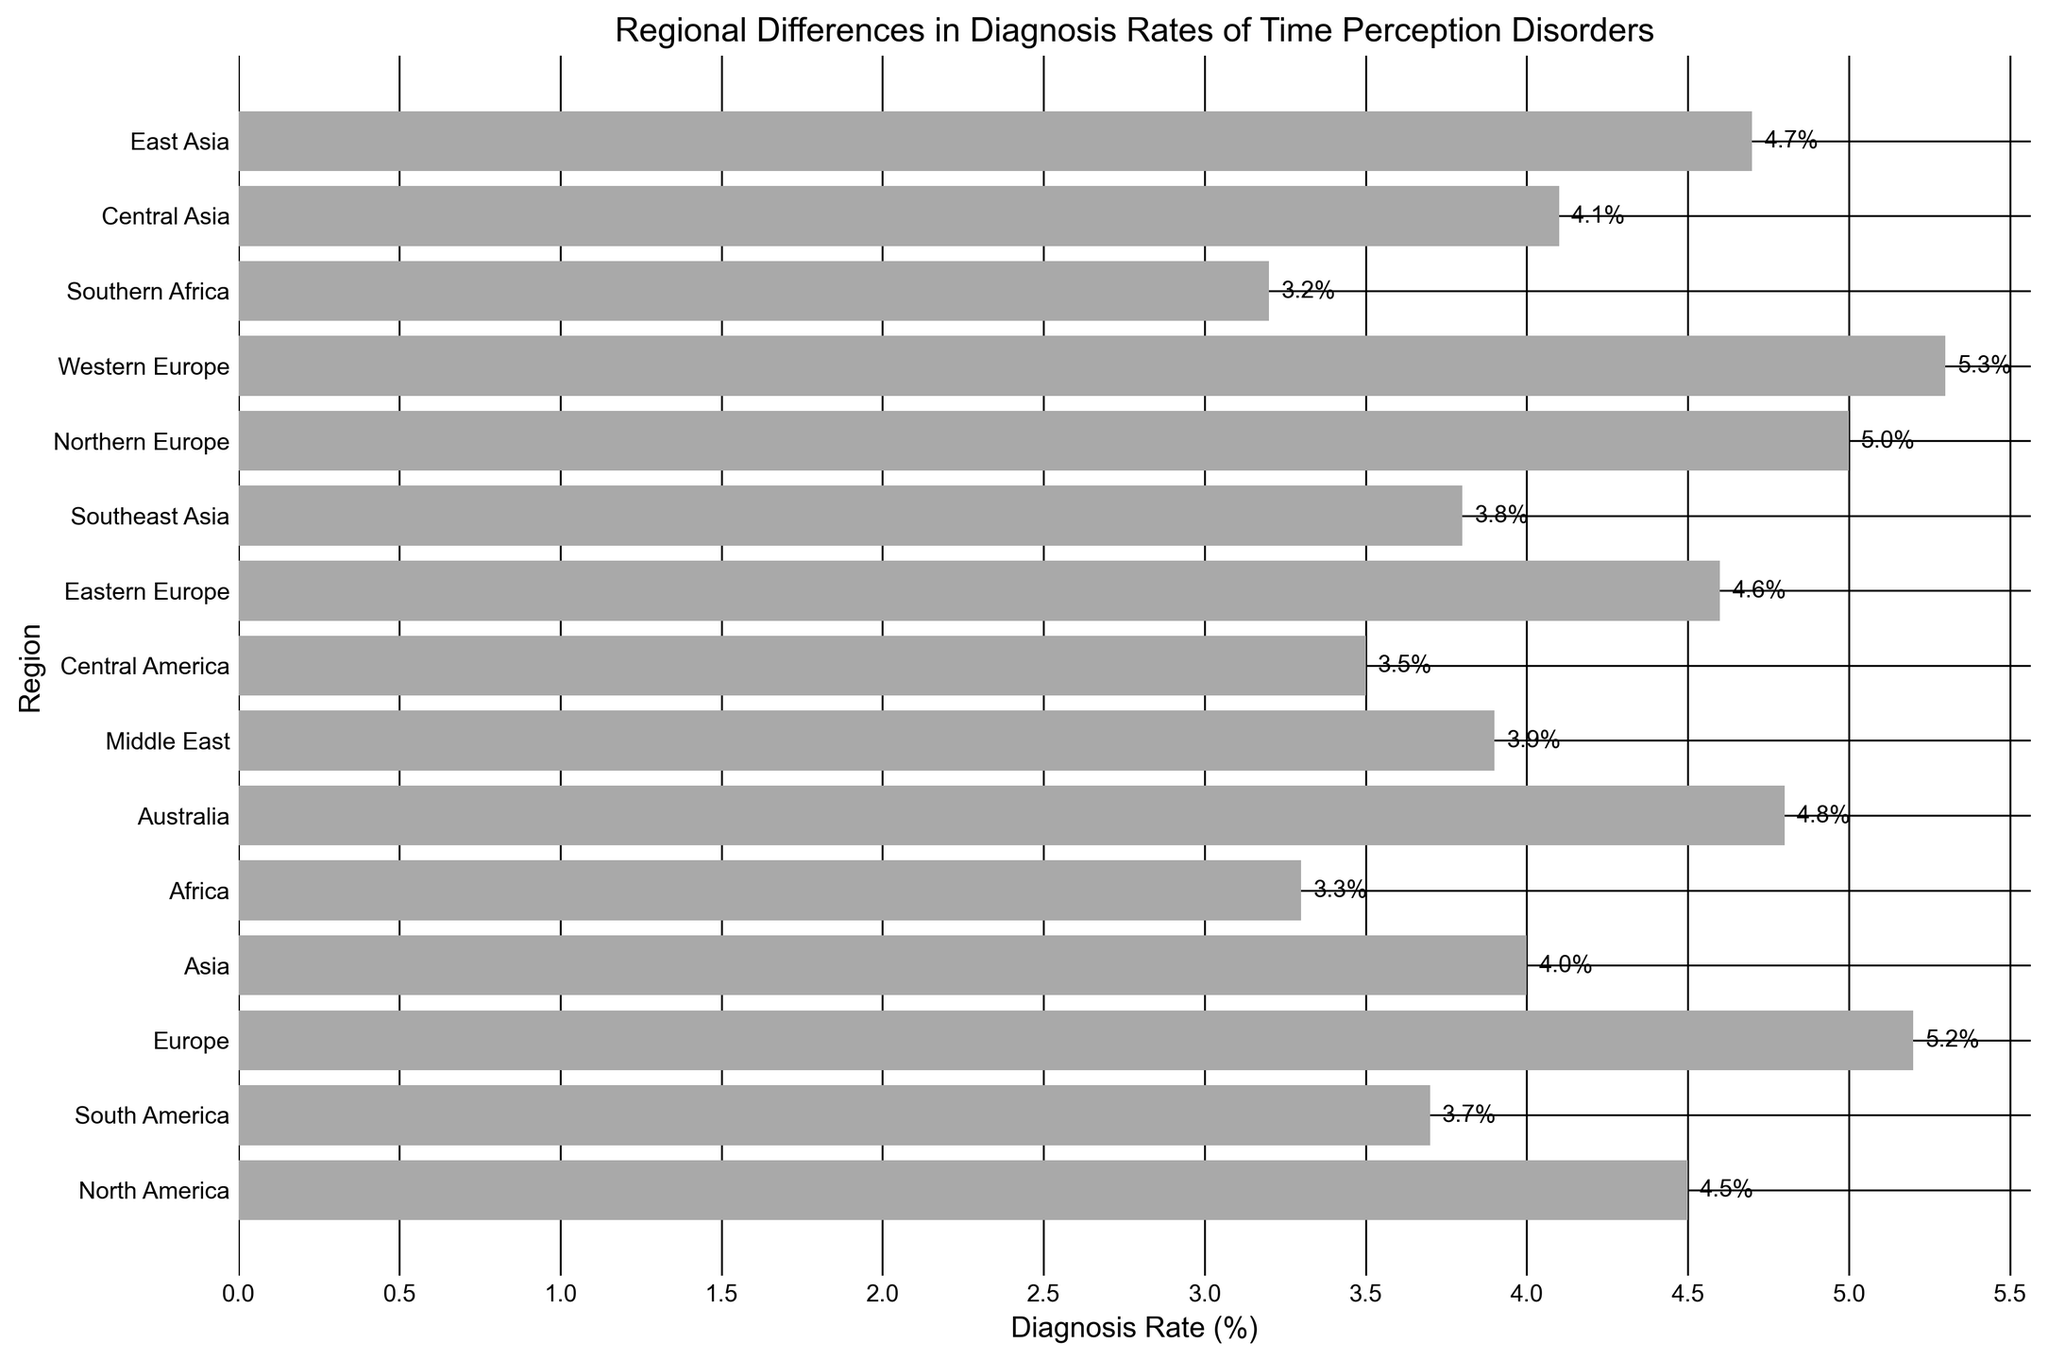Which region has the highest diagnosis rate of time perception disorders? Look at the bar chart and identify the region with the longest horizontal bar. The highest bar represents the highest diagnosis rate.
Answer: Western Europe Which region has the lowest diagnosis rate of time perception disorders? Identify the region with the shortest horizontal bar. The shortest bar represents the lowest diagnosis rate.
Answer: Southern Africa What is the difference in diagnosis rates between Northern Europe and Asia? Find the lengths of the bars representing Northern Europe and Asia. Subtract the diagnosis rate of Asia (4.0%) from Northern Europe (5.0%).
Answer: 1.0% Which regions have a diagnosis rate equal to or greater than 4.5%? Identify and list all regions with bars extending to 4.5% or greater.
Answer: Northern Europe, Australia, Eastern Europe, Western Europe, Europe What is the average diagnosis rate across all regions? Sum all the diagnosis rates from the bars and divide by the total number of regions (15). Calculation: (4.5 + 3.7 + 5.2 + 4.0 + 3.3 + 4.8 + 3.9 + 3.5 + 4.6 + 3.8 + 5.0 + 5.3 + 3.2 + 4.1 + 4.7) / 15 = 4.165%.
Answer: 4.165% What is the combined diagnosis rate of North America, South America, and Central America? Add the diagnosis rates of North America (4.5%), South America (3.7%), and Central America (3.5%). Calculation: 4.5 + 3.7 + 3.5 = 11.7%.
Answer: 11.7% Is the diagnosis rate of Eastern Europe greater than that of Central Asia? By how much? Compare the lengths of the bars for Eastern Europe (4.6%) and Central Asia (4.1%). Subtract the rate of Central Asia from Eastern Europe.
Answer: 0.5% How many regions have diagnosis rates below 4.0%? Count the number of bars that do not extend to the 4.0% mark.
Answer: 5 What is the range of diagnosis rates in the figure? Determine the highest diagnosis rate (Western Europe, 5.3%) and the lowest (Southern Africa, 3.2%), then subtract the lowest from the highest.
Answer: 2.1% Which region has a diagnosis rate closest to the overall average rate of 4.165%? After calculating the average rate (4.165%), identify the region whose diagnosis rate is closest to this value. Central Asia's rate (4.1%) is the nearest to the average.
Answer: Central Asia 